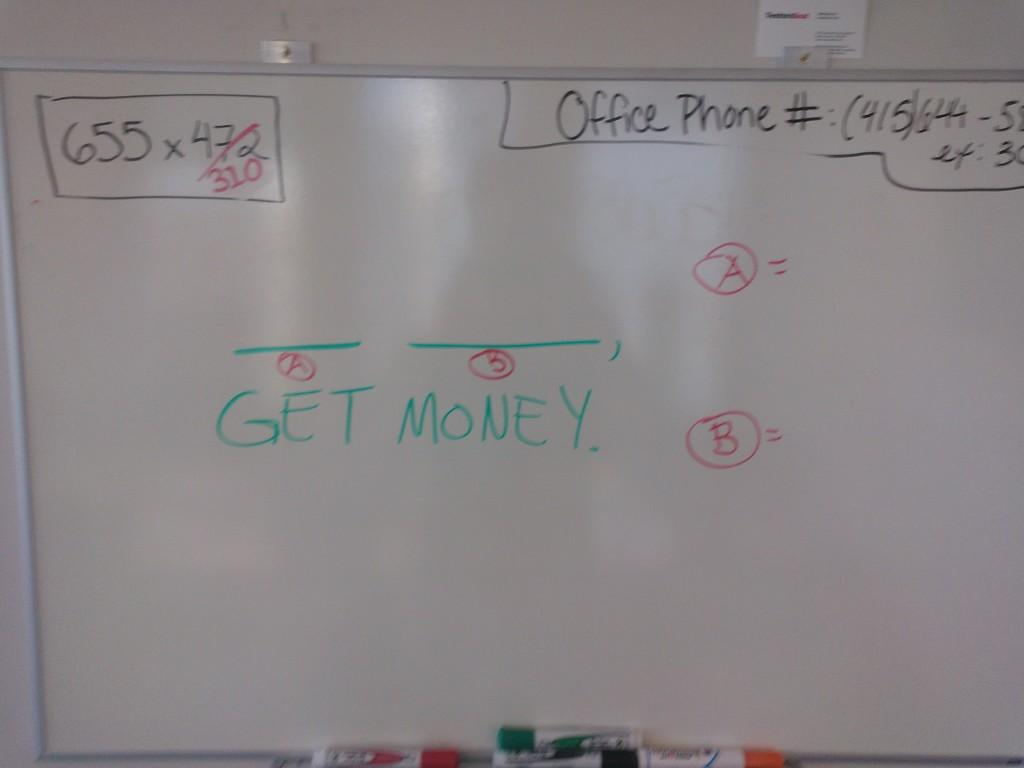<image>
Render a clear and concise summary of the photo. A white board with several things written on it including a phone number labeled "Office Phone" and the words, "Get Money." 